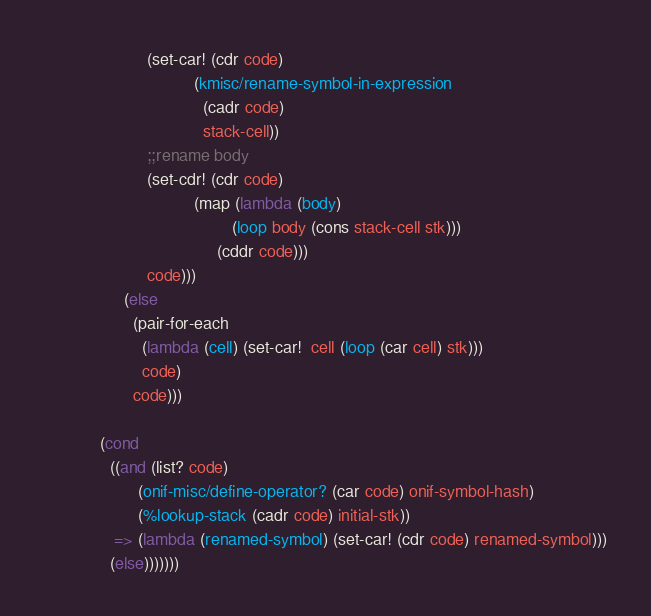<code> <loc_0><loc_0><loc_500><loc_500><_Scheme_>                      (set-car! (cdr code)
                                (kmisc/rename-symbol-in-expression
                                  (cadr code)
                                  stack-cell))
                      ;;rename body
                      (set-cdr! (cdr code)
                                (map (lambda (body)
                                        (loop body (cons stack-cell stk)))
                                     (cddr code)))
                      code)))
                 (else
                   (pair-for-each
                     (lambda (cell) (set-car!  cell (loop (car cell) stk)))
                     code)
                   code)))

            (cond
              ((and (list? code)
                    (onif-misc/define-operator? (car code) onif-symbol-hash)
                    (%lookup-stack (cadr code) initial-stk))
               => (lambda (renamed-symbol) (set-car! (cdr code) renamed-symbol)))
              (else)))))))
</code> 